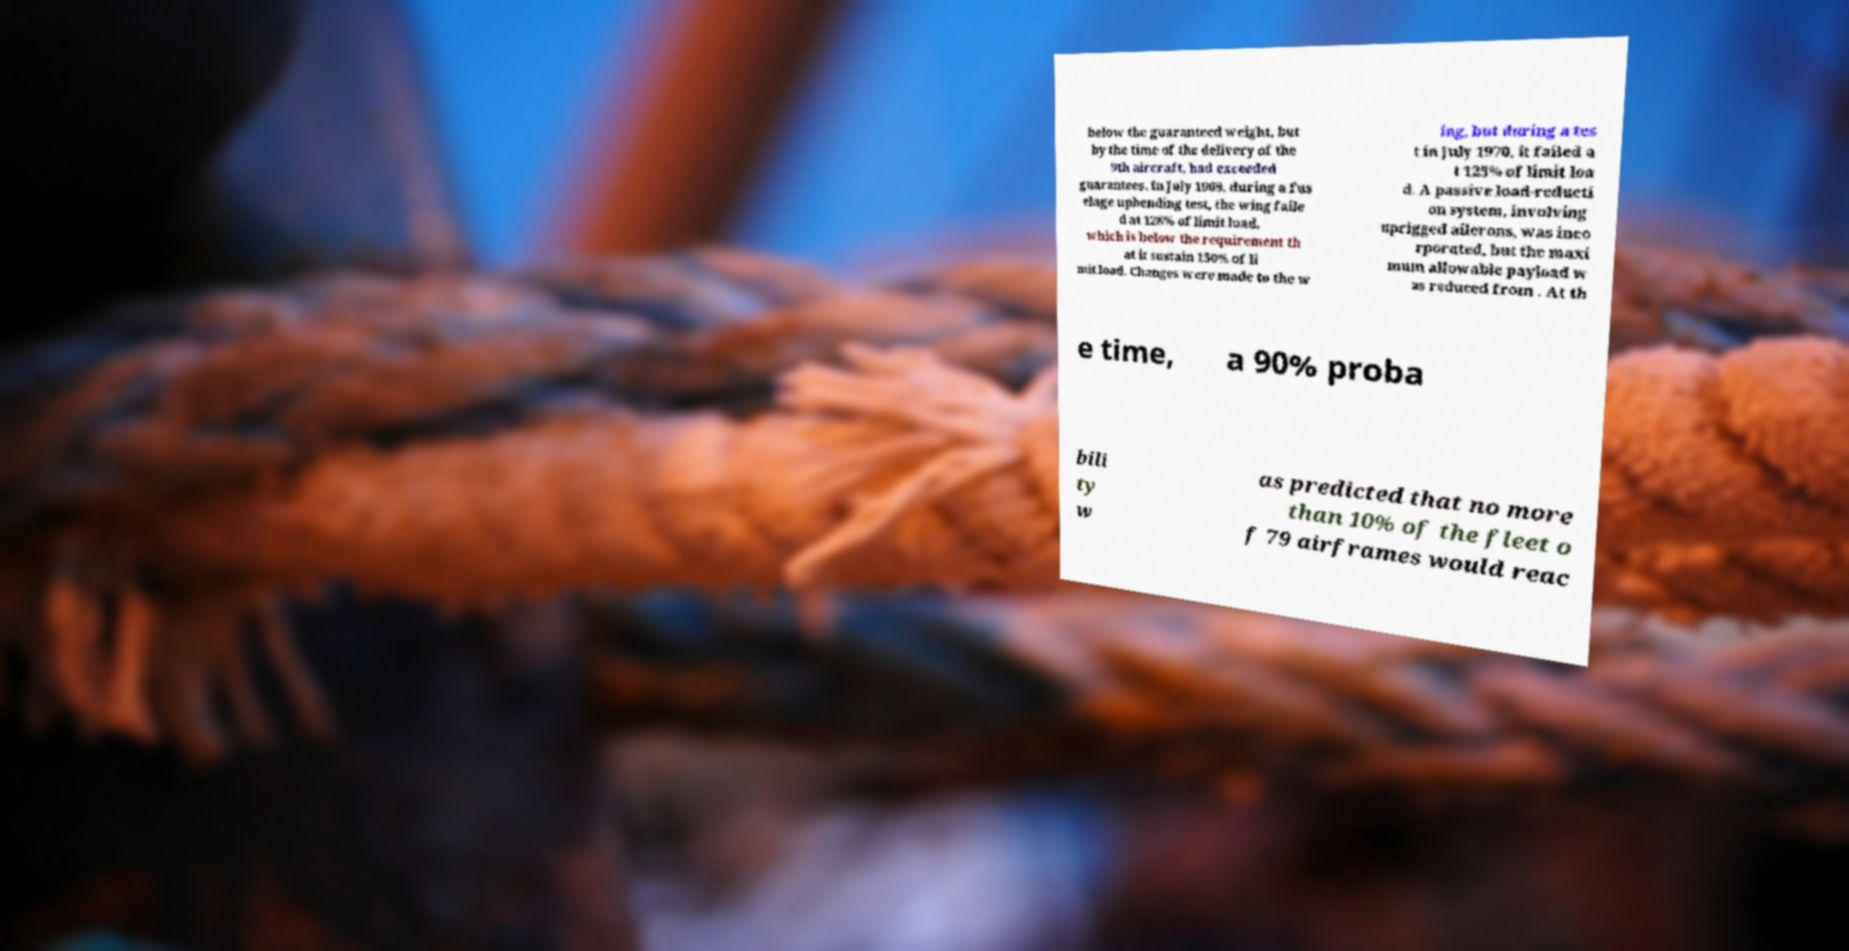I need the written content from this picture converted into text. Can you do that? below the guaranteed weight, but by the time of the delivery of the 9th aircraft, had exceeded guarantees. In July 1969, during a fus elage upbending test, the wing faile d at 128% of limit load, which is below the requirement th at it sustain 150% of li mit load. Changes were made to the w ing, but during a tes t in July 1970, it failed a t 125% of limit loa d. A passive load-reducti on system, involving uprigged ailerons, was inco rporated, but the maxi mum allowable payload w as reduced from . At th e time, a 90% proba bili ty w as predicted that no more than 10% of the fleet o f 79 airframes would reac 